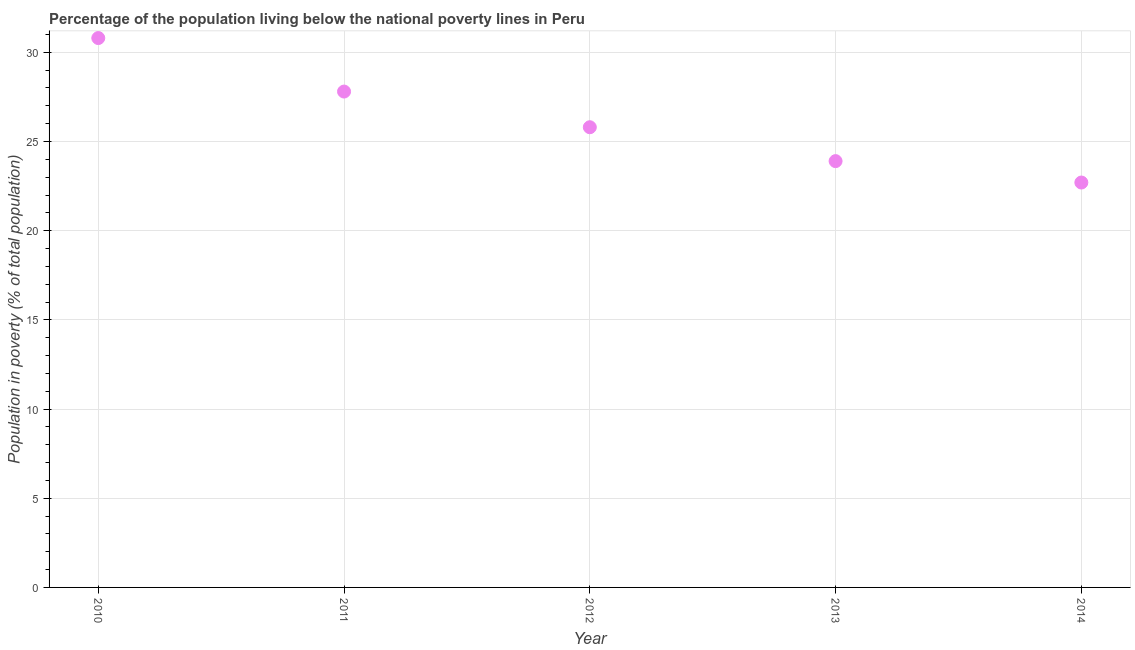What is the percentage of population living below poverty line in 2013?
Provide a succinct answer. 23.9. Across all years, what is the maximum percentage of population living below poverty line?
Make the answer very short. 30.8. Across all years, what is the minimum percentage of population living below poverty line?
Your response must be concise. 22.7. In which year was the percentage of population living below poverty line minimum?
Your answer should be very brief. 2014. What is the sum of the percentage of population living below poverty line?
Your answer should be compact. 131. What is the difference between the percentage of population living below poverty line in 2012 and 2014?
Keep it short and to the point. 3.1. What is the average percentage of population living below poverty line per year?
Offer a terse response. 26.2. What is the median percentage of population living below poverty line?
Give a very brief answer. 25.8. Do a majority of the years between 2011 and 2014 (inclusive) have percentage of population living below poverty line greater than 17 %?
Make the answer very short. Yes. What is the ratio of the percentage of population living below poverty line in 2011 to that in 2012?
Offer a terse response. 1.08. Is the sum of the percentage of population living below poverty line in 2013 and 2014 greater than the maximum percentage of population living below poverty line across all years?
Offer a terse response. Yes. What is the difference between the highest and the lowest percentage of population living below poverty line?
Give a very brief answer. 8.1. How many dotlines are there?
Your answer should be compact. 1. Are the values on the major ticks of Y-axis written in scientific E-notation?
Give a very brief answer. No. Does the graph contain any zero values?
Provide a succinct answer. No. What is the title of the graph?
Offer a very short reply. Percentage of the population living below the national poverty lines in Peru. What is the label or title of the Y-axis?
Provide a succinct answer. Population in poverty (% of total population). What is the Population in poverty (% of total population) in 2010?
Ensure brevity in your answer.  30.8. What is the Population in poverty (% of total population) in 2011?
Your response must be concise. 27.8. What is the Population in poverty (% of total population) in 2012?
Your answer should be compact. 25.8. What is the Population in poverty (% of total population) in 2013?
Keep it short and to the point. 23.9. What is the Population in poverty (% of total population) in 2014?
Ensure brevity in your answer.  22.7. What is the difference between the Population in poverty (% of total population) in 2011 and 2012?
Give a very brief answer. 2. What is the difference between the Population in poverty (% of total population) in 2011 and 2014?
Offer a very short reply. 5.1. What is the ratio of the Population in poverty (% of total population) in 2010 to that in 2011?
Your answer should be very brief. 1.11. What is the ratio of the Population in poverty (% of total population) in 2010 to that in 2012?
Keep it short and to the point. 1.19. What is the ratio of the Population in poverty (% of total population) in 2010 to that in 2013?
Your answer should be very brief. 1.29. What is the ratio of the Population in poverty (% of total population) in 2010 to that in 2014?
Provide a short and direct response. 1.36. What is the ratio of the Population in poverty (% of total population) in 2011 to that in 2012?
Your answer should be very brief. 1.08. What is the ratio of the Population in poverty (% of total population) in 2011 to that in 2013?
Your answer should be compact. 1.16. What is the ratio of the Population in poverty (% of total population) in 2011 to that in 2014?
Make the answer very short. 1.23. What is the ratio of the Population in poverty (% of total population) in 2012 to that in 2013?
Provide a succinct answer. 1.08. What is the ratio of the Population in poverty (% of total population) in 2012 to that in 2014?
Your answer should be compact. 1.14. What is the ratio of the Population in poverty (% of total population) in 2013 to that in 2014?
Keep it short and to the point. 1.05. 